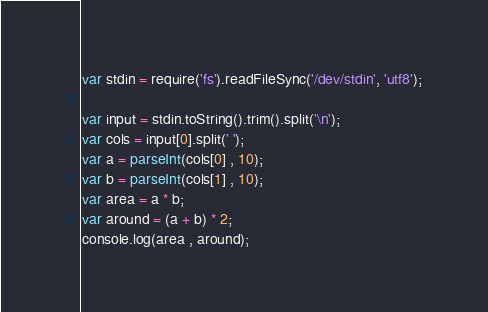Convert code to text. <code><loc_0><loc_0><loc_500><loc_500><_JavaScript_>var stdin = require('fs').readFileSync('/dev/stdin', 'utf8');

var input = stdin.toString().trim().split('\n');
var cols = input[0].split(' ');
var a = parseInt(cols[0] , 10);
var b = parseInt(cols[1] , 10);
var area = a * b;
var around = (a + b) * 2;
console.log(area , around);</code> 